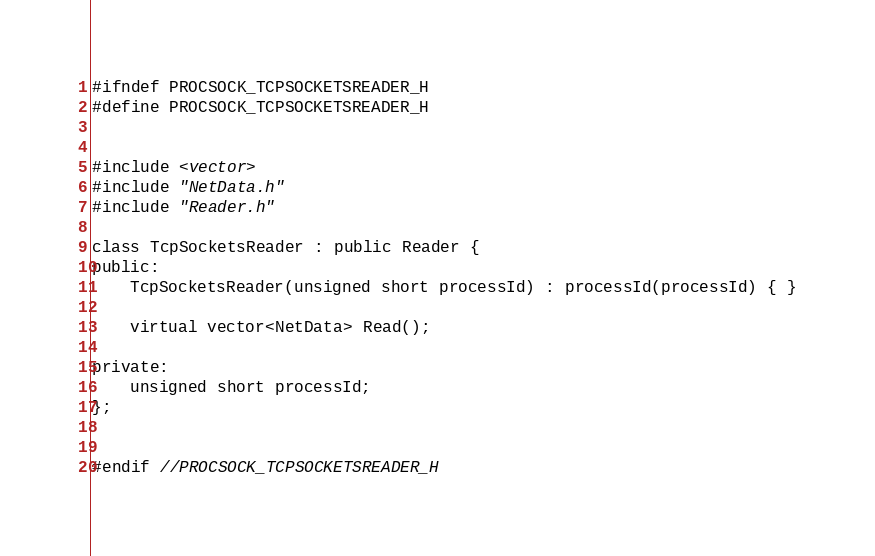Convert code to text. <code><loc_0><loc_0><loc_500><loc_500><_C_>#ifndef PROCSOCK_TCPSOCKETSREADER_H
#define PROCSOCK_TCPSOCKETSREADER_H


#include <vector>
#include "NetData.h"
#include "Reader.h"

class TcpSocketsReader : public Reader {
public:
    TcpSocketsReader(unsigned short processId) : processId(processId) { }

    virtual vector<NetData> Read();

private:
    unsigned short processId;
};


#endif //PROCSOCK_TCPSOCKETSREADER_H
</code> 